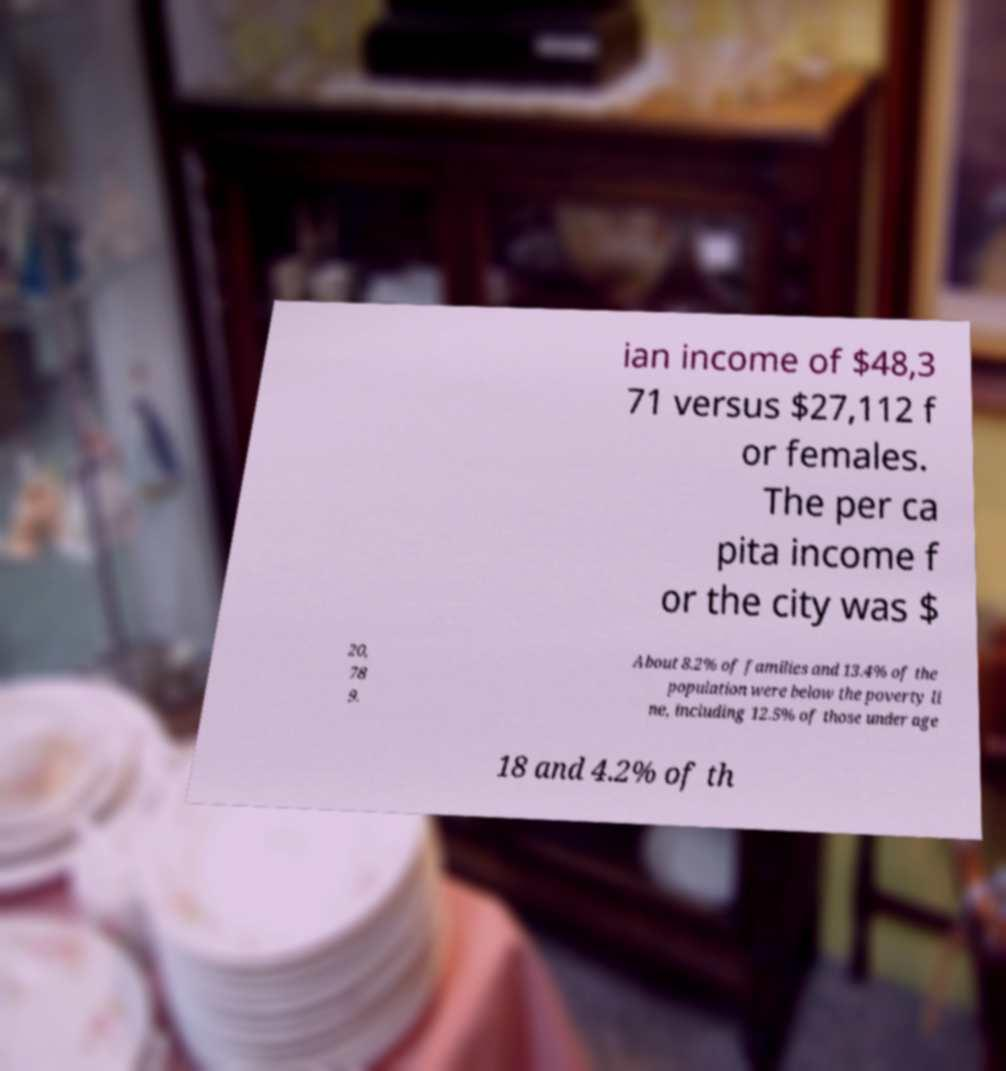I need the written content from this picture converted into text. Can you do that? ian income of $48,3 71 versus $27,112 f or females. The per ca pita income f or the city was $ 20, 78 9. About 8.2% of families and 13.4% of the population were below the poverty li ne, including 12.5% of those under age 18 and 4.2% of th 